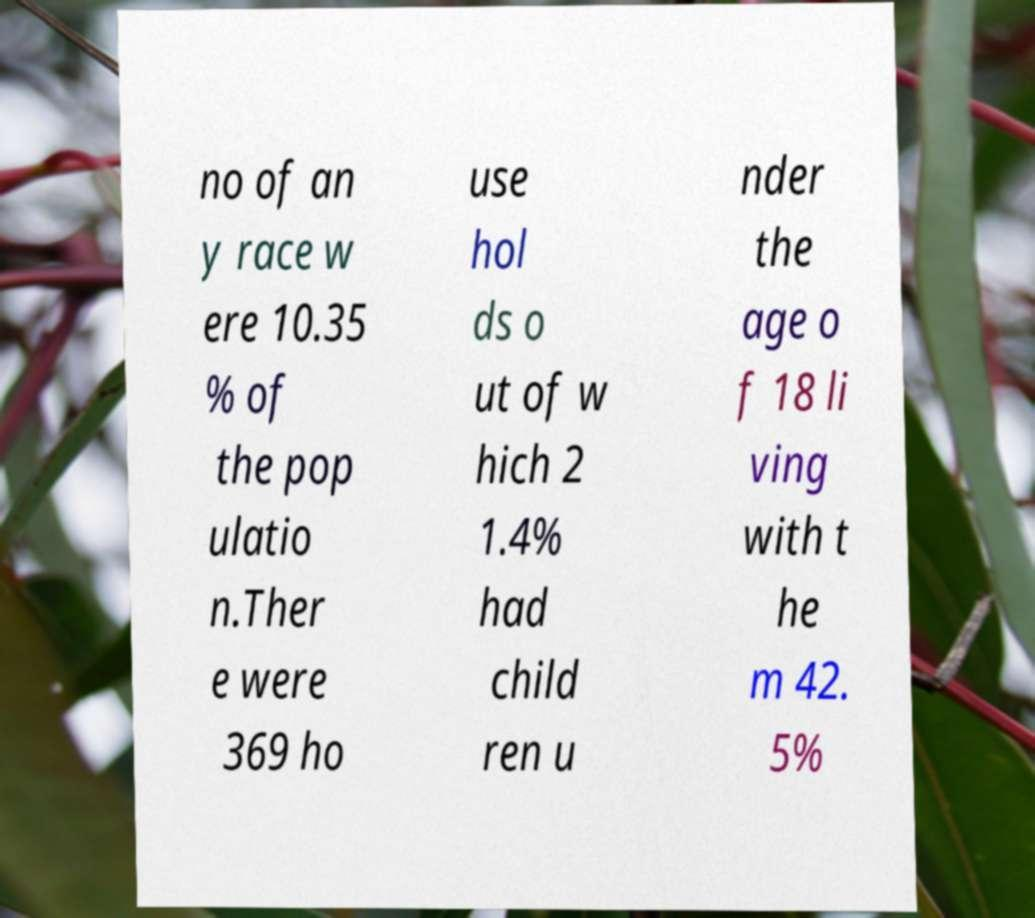Could you extract and type out the text from this image? no of an y race w ere 10.35 % of the pop ulatio n.Ther e were 369 ho use hol ds o ut of w hich 2 1.4% had child ren u nder the age o f 18 li ving with t he m 42. 5% 